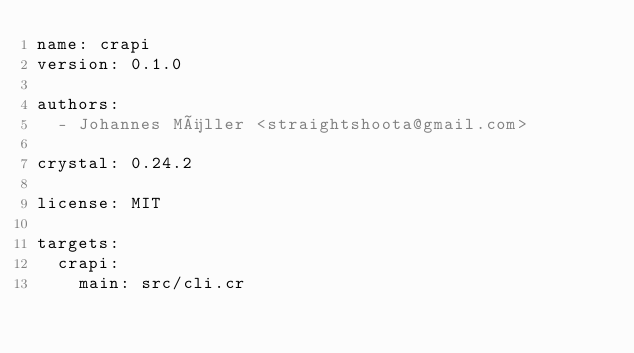Convert code to text. <code><loc_0><loc_0><loc_500><loc_500><_YAML_>name: crapi
version: 0.1.0

authors:
  - Johannes Müller <straightshoota@gmail.com>

crystal: 0.24.2

license: MIT

targets:
  crapi:
    main: src/cli.cr
</code> 